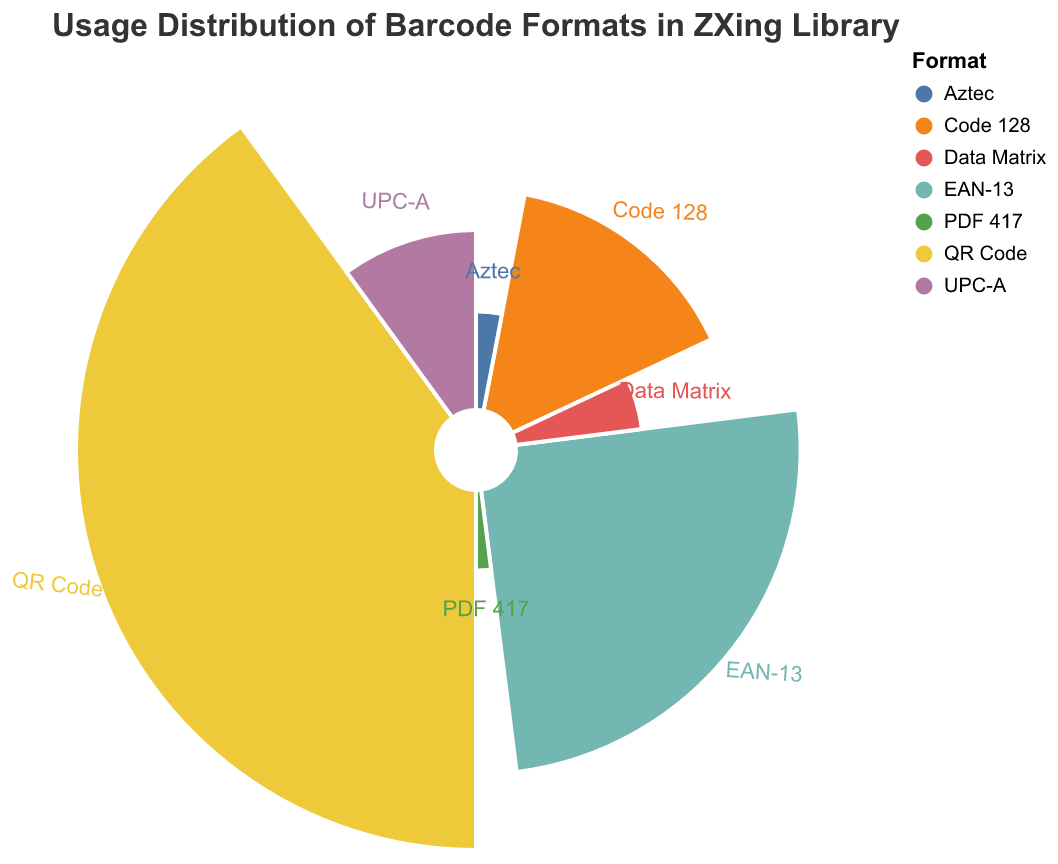What is the most popular barcode format in the ZXing Library? The chart shows the usage distribution in percentage for each barcode format, and QR Code has the highest percentage at 40%.
Answer: QR Code Which barcode format has the lowest usage percentage? By looking at the segment with the smallest percentage, PDF 417 has the smallest segment, which is 2%.
Answer: PDF 417 What is the total usage percentage of QR Code, EAN-13, and Code 128 combined? The usage percentages for QR Code, EAN-13, and Code 128 are 40%, 25%, and 15% respectively. Adding them together, 40 + 25 + 15 = 80%.
Answer: 80% How does the popularity of UPC-A compare to Data Matrix? UPC-A has a usage percentage of 10%, while Data Matrix has a usage percentage of 5%. Thus, UPC-A is twice as popular as Data Matrix.
Answer: UPC-A is twice as popular What percentage of usage do the least popular barcodes, Aztec and PDF 417, account for together? Aztec has a 3% usage and PDF 417 has a 2% usage. Adding them together, 3 + 2 = 5%.
Answer: 5% Which formats have a usage percentage greater than Data Matrix? Data Matrix has a 5% usage percentage. The formats with higher percentages are QR Code (40%), EAN-13 (25%), Code 128 (15%), and UPC-A (10%).
Answer: QR Code, EAN-13, Code 128, UPC-A What's the difference in usage percentage between the most popular (QR Code) and the least popular (PDF 417) barcode formats? QR Code has a 40% usage, and PDF 417 has a 2% usage. The difference is 40 - 2 = 38%.
Answer: 38% What percentage of the total does the middle category, UPC-A, represent in the chart? UPC-A has a usage percentage of 10%.
Answer: 10% How does the sum of the usage percentages of the three least popular formats compare to the usage percentage of EAN-13? The three least popular formats are Data Matrix (5%), Aztec (3%), and PDF 417 (2%). The sum is 5 + 3 + 2 = 10%. EAN-13 has a 25% usage, so EAN-13 is 15% higher than the combined usage of the three least popular formats.
Answer: EAN-13 is 15% higher What proportion of the chart is made up by the QR Code and UPC-A formats together? QR Code has 40% and UPC-A has 10%. Together, they account for 40 + 10 = 50% of the chart.
Answer: 50% 